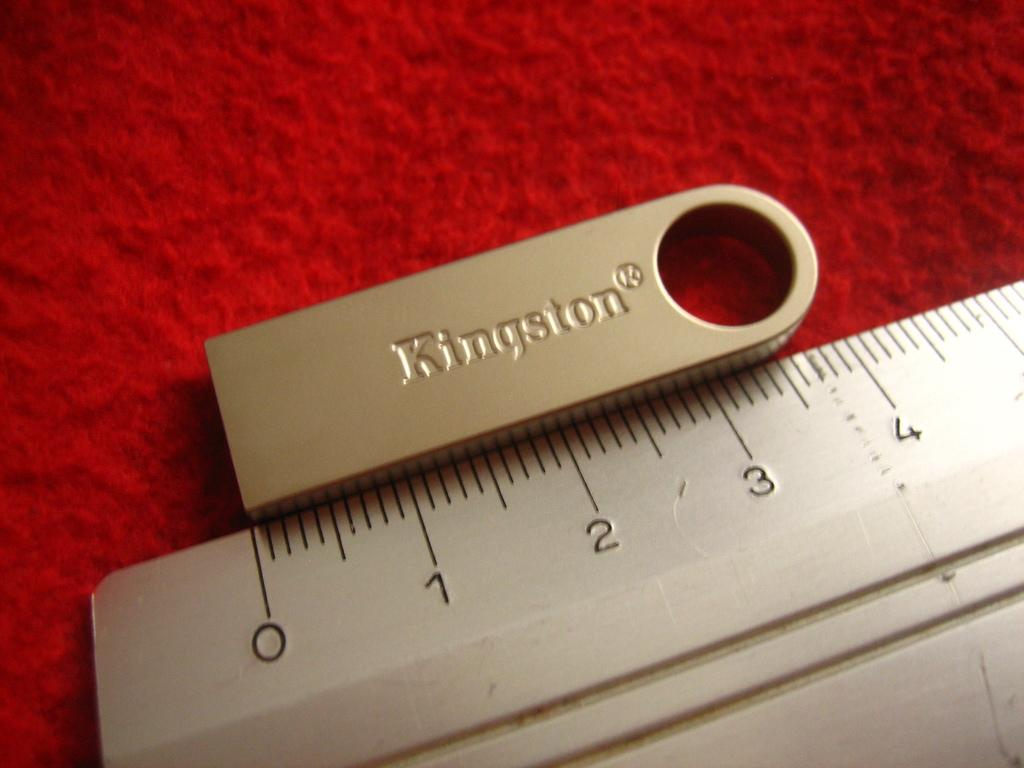<image>
Present a compact description of the photo's key features. A Kingston flash drive measures about 4 inches. 